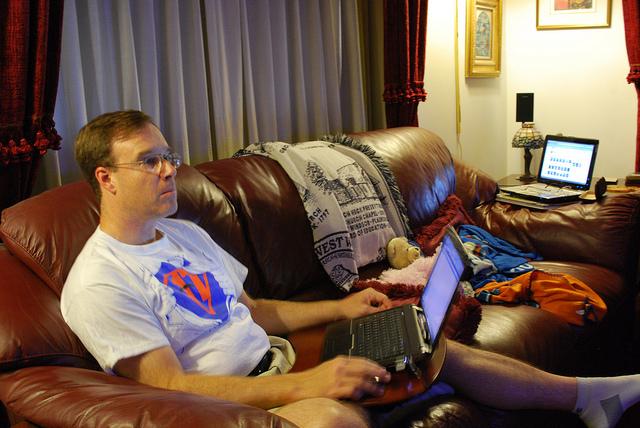What color is the logo on the man's shirt?
Keep it brief. Blue and red. How many laptops are visible?
Concise answer only. 2. Is this man watching TV?
Be succinct. Yes. 